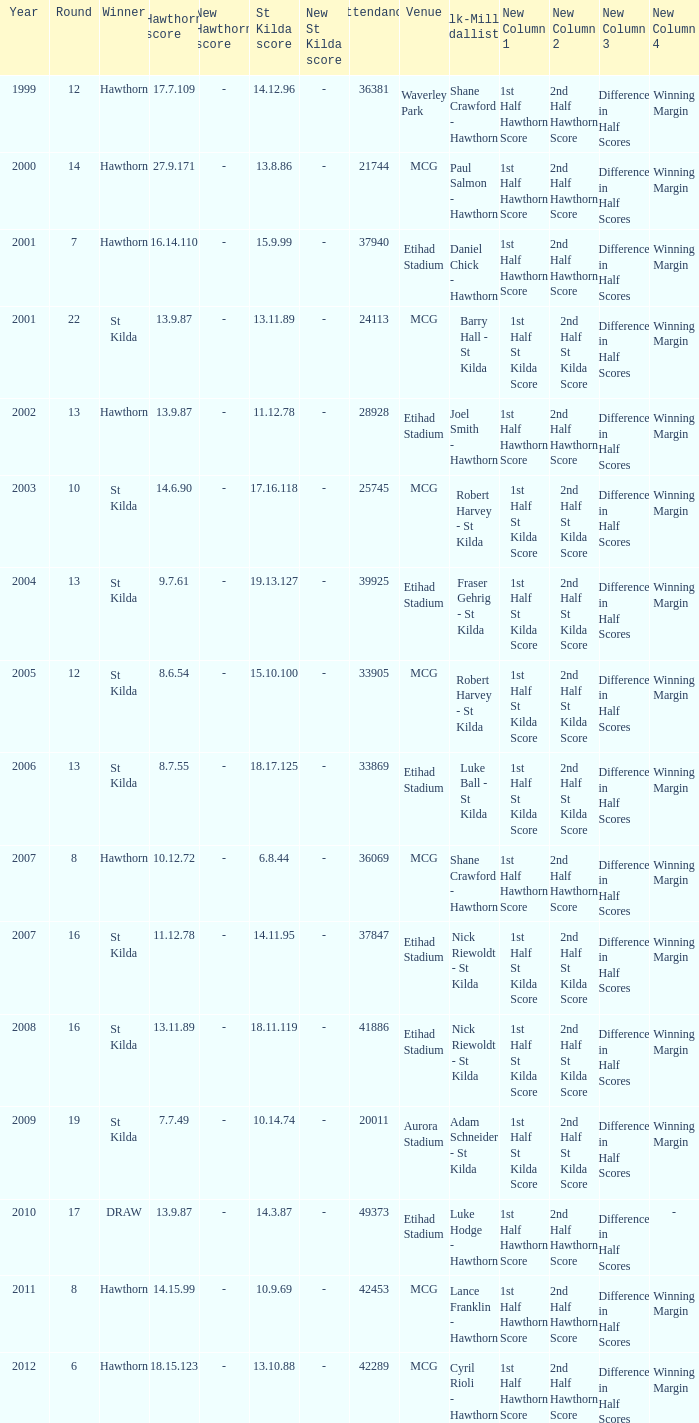Help me parse the entirety of this table. {'header': ['Year', 'Round', 'Winner', 'Hawthorn score', 'New Hawthorn score', 'St Kilda score', 'New St Kilda score', 'Attendance', 'Venue', 'Silk-Miller Medallist', 'New Column 1', 'New Column 2', 'New Column 3', 'New Column 4'], 'rows': [['1999', '12', 'Hawthorn', '17.7.109', '-', '14.12.96', '-', '36381', 'Waverley Park', 'Shane Crawford - Hawthorn', '1st Half Hawthorn Score', '2nd Half Hawthorn Score', 'Difference in Half Scores', 'Winning Margin'], ['2000', '14', 'Hawthorn', '27.9.171', '-', '13.8.86', '-', '21744', 'MCG', 'Paul Salmon - Hawthorn', '1st Half Hawthorn Score', '2nd Half Hawthorn Score', 'Difference in Half Scores', 'Winning Margin'], ['2001', '7', 'Hawthorn', '16.14.110', '-', '15.9.99', '-', '37940', 'Etihad Stadium', 'Daniel Chick - Hawthorn', '1st Half Hawthorn Score', '2nd Half Hawthorn Score', 'Difference in Half Scores', 'Winning Margin'], ['2001', '22', 'St Kilda', '13.9.87', '-', '13.11.89', '-', '24113', 'MCG', 'Barry Hall - St Kilda', '1st Half St Kilda Score', '2nd Half St Kilda Score', 'Difference in Half Scores', 'Winning Margin'], ['2002', '13', 'Hawthorn', '13.9.87', '-', '11.12.78', '-', '28928', 'Etihad Stadium', 'Joel Smith - Hawthorn', '1st Half Hawthorn Score', '2nd Half Hawthorn Score', 'Difference in Half Scores', 'Winning Margin'], ['2003', '10', 'St Kilda', '14.6.90', '-', '17.16.118', '-', '25745', 'MCG', 'Robert Harvey - St Kilda', '1st Half St Kilda Score', '2nd Half St Kilda Score', 'Difference in Half Scores', 'Winning Margin'], ['2004', '13', 'St Kilda', '9.7.61', '-', '19.13.127', '-', '39925', 'Etihad Stadium', 'Fraser Gehrig - St Kilda', '1st Half St Kilda Score', '2nd Half St Kilda Score', 'Difference in Half Scores', 'Winning Margin'], ['2005', '12', 'St Kilda', '8.6.54', '-', '15.10.100', '-', '33905', 'MCG', 'Robert Harvey - St Kilda', '1st Half St Kilda Score', '2nd Half St Kilda Score', 'Difference in Half Scores', 'Winning Margin'], ['2006', '13', 'St Kilda', '8.7.55', '-', '18.17.125', '-', '33869', 'Etihad Stadium', 'Luke Ball - St Kilda', '1st Half St Kilda Score', '2nd Half St Kilda Score', 'Difference in Half Scores', 'Winning Margin'], ['2007', '8', 'Hawthorn', '10.12.72', '-', '6.8.44', '-', '36069', 'MCG', 'Shane Crawford - Hawthorn', '1st Half Hawthorn Score', '2nd Half Hawthorn Score', 'Difference in Half Scores', 'Winning Margin'], ['2007', '16', 'St Kilda', '11.12.78', '-', '14.11.95', '-', '37847', 'Etihad Stadium', 'Nick Riewoldt - St Kilda', '1st Half St Kilda Score', '2nd Half St Kilda Score', 'Difference in Half Scores', 'Winning Margin'], ['2008', '16', 'St Kilda', '13.11.89', '-', '18.11.119', '-', '41886', 'Etihad Stadium', 'Nick Riewoldt - St Kilda', '1st Half St Kilda Score', '2nd Half St Kilda Score', 'Difference in Half Scores', 'Winning Margin'], ['2009', '19', 'St Kilda', '7.7.49', '-', '10.14.74', '-', '20011', 'Aurora Stadium', 'Adam Schneider - St Kilda', '1st Half St Kilda Score', '2nd Half St Kilda Score', 'Difference in Half Scores', 'Winning Margin'], ['2010', '17', 'DRAW', '13.9.87', '-', '14.3.87', '-', '49373', 'Etihad Stadium', 'Luke Hodge - Hawthorn', '1st Half Hawthorn Score', '2nd Half Hawthorn Score', 'Difference in Half Scores', '-'], ['2011', '8', 'Hawthorn', '14.15.99', '-', '10.9.69', '-', '42453', 'MCG', 'Lance Franklin - Hawthorn', '1st Half Hawthorn Score', '2nd Half Hawthorn Score', 'Difference in Half Scores', 'Winning Margin'], ['2012', '6', 'Hawthorn', '18.15.123', '-', '13.10.88', '-', '42289', 'MCG', 'Cyril Rioli - Hawthorn', '1st Half Hawthorn Score', '2nd Half Hawthorn Score', 'Difference in Half Scores', 'Winning Margin']]} Who is the winner when the st kilda score is 13.10.88? Hawthorn. 